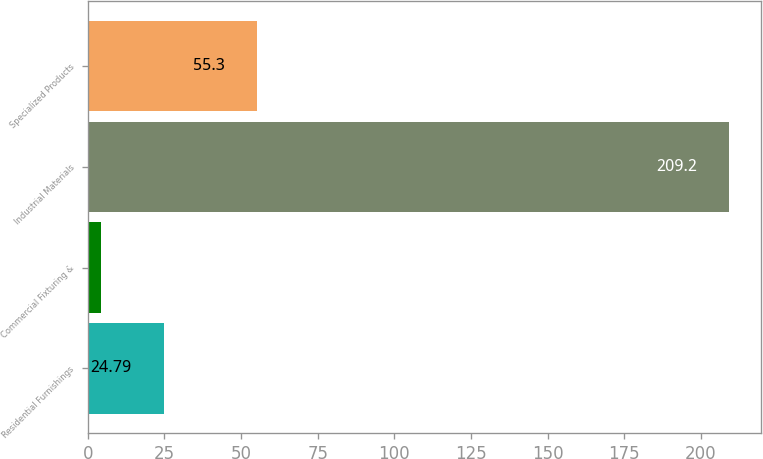<chart> <loc_0><loc_0><loc_500><loc_500><bar_chart><fcel>Residential Furnishings<fcel>Commercial Fixturing &<fcel>Industrial Materials<fcel>Specialized Products<nl><fcel>24.79<fcel>4.3<fcel>209.2<fcel>55.3<nl></chart> 